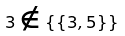<formula> <loc_0><loc_0><loc_500><loc_500>3 \notin \{ \{ 3 , 5 \} \}</formula> 